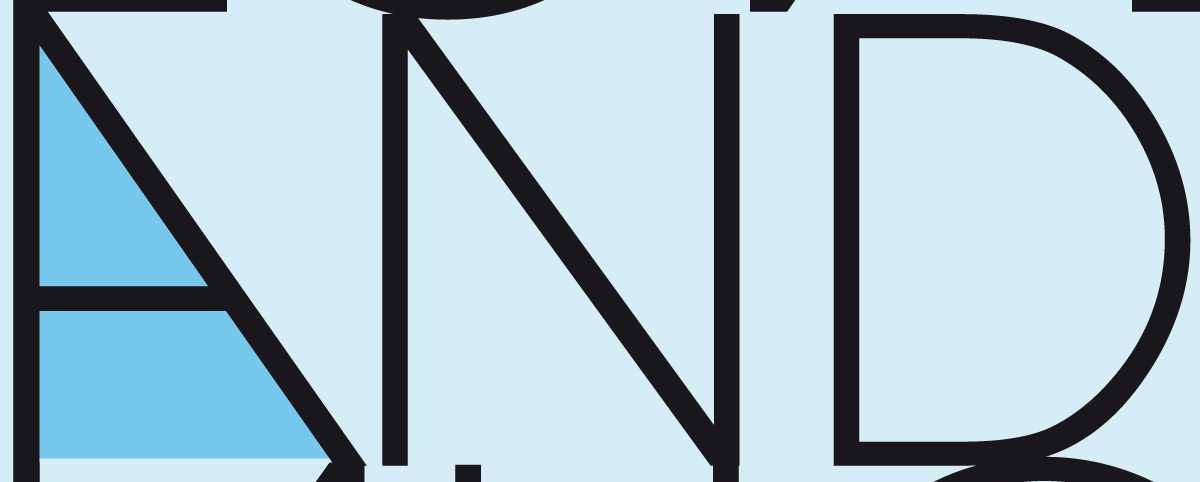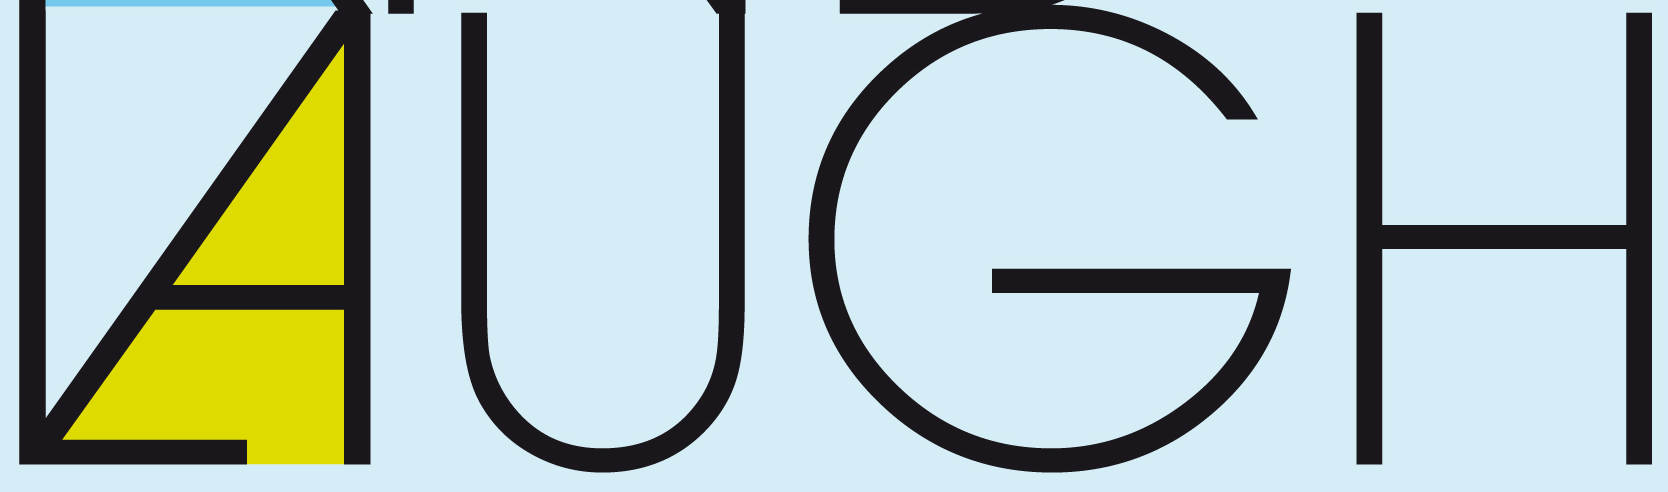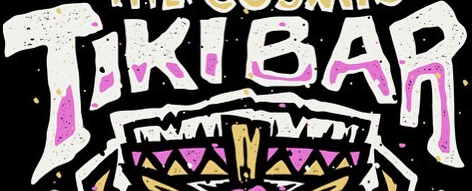What words can you see in these images in sequence, separated by a semicolon? AND; LAUGH; TIKIBAR 